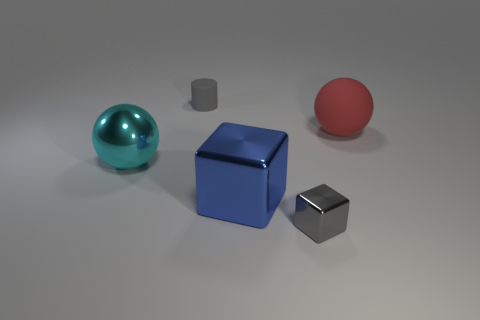Add 1 gray matte things. How many objects exist? 6 Subtract all cubes. How many objects are left? 3 Add 5 small cyan matte things. How many small cyan matte things exist? 5 Subtract 0 brown cylinders. How many objects are left? 5 Subtract all blocks. Subtract all metallic balls. How many objects are left? 2 Add 2 cyan shiny things. How many cyan shiny things are left? 3 